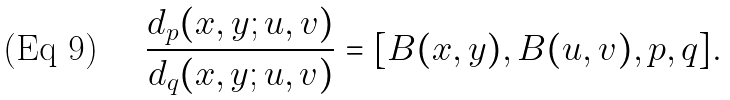Convert formula to latex. <formula><loc_0><loc_0><loc_500><loc_500>\frac { d _ { p } ( x , y ; u , v ) } { d _ { q } ( x , y ; u , v ) } = [ B ( x , y ) , B ( u , v ) , p , q ] .</formula> 